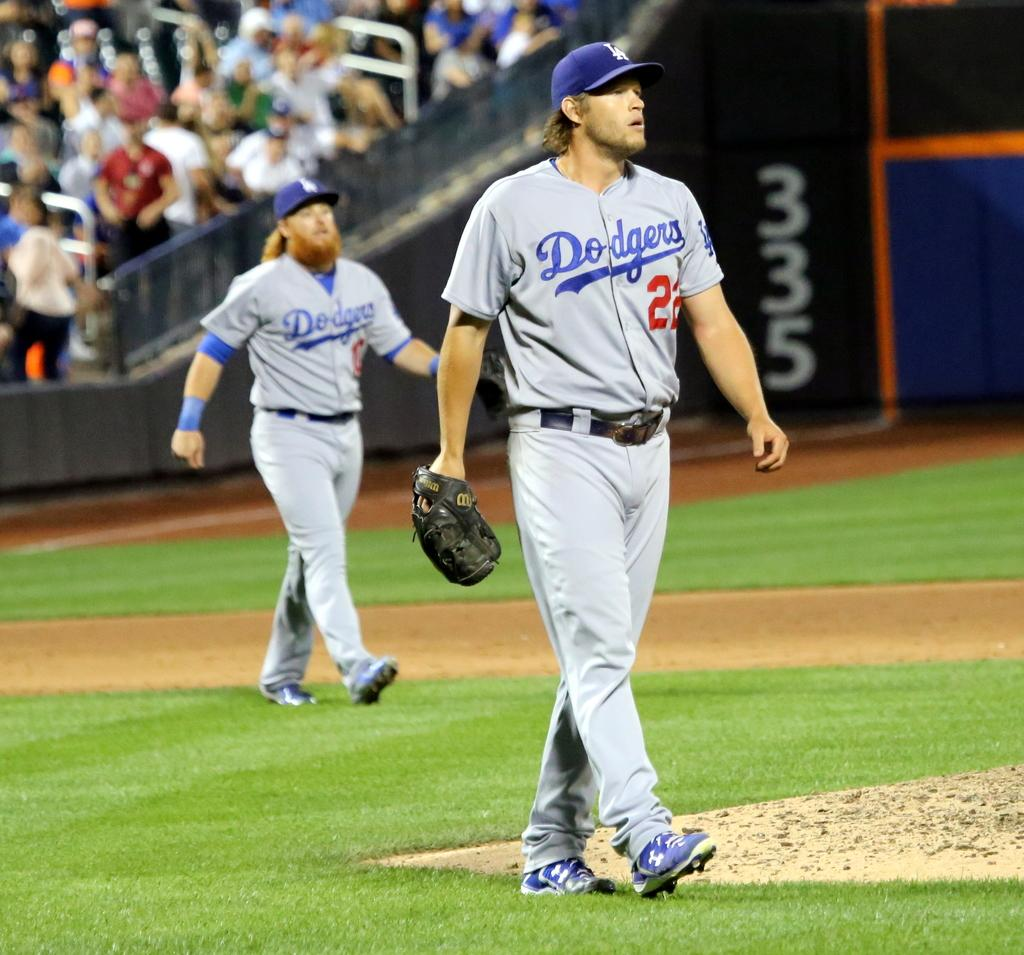<image>
Give a short and clear explanation of the subsequent image. Two men in Dodgers uniforms are on the field. 